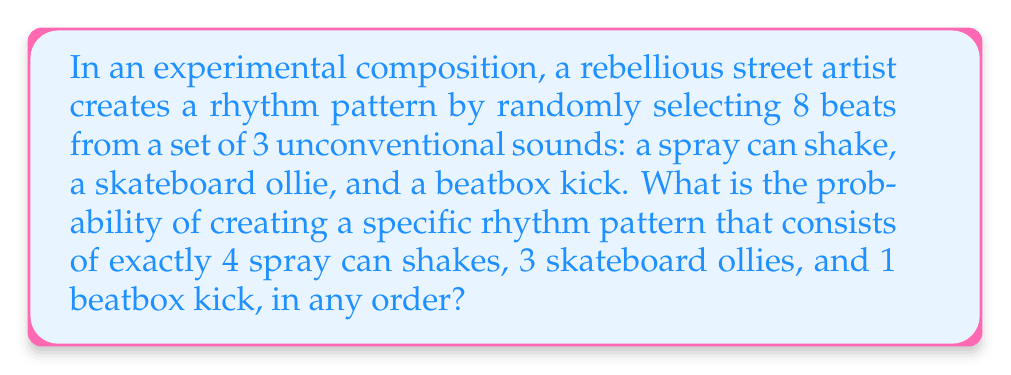Solve this math problem. Let's approach this step-by-step:

1) This is a combination problem where order matters. We can use the multinomial coefficient to solve it.

2) The total number of beats is 8, and we need to distribute them into 3 categories:
   - 4 spray can shakes
   - 3 skateboard ollies
   - 1 beatbox kick

3) The formula for the multinomial coefficient is:

   $$\binom{n}{n_1, n_2, ..., n_k} = \frac{n!}{n_1! \cdot n_2! \cdot ... \cdot n_k!}$$

   Where $n$ is the total number of items, and $n_1, n_2, ..., n_k$ are the number of items in each category.

4) In our case:
   $n = 8$ (total beats)
   $n_1 = 4$ (spray can shakes)
   $n_2 = 3$ (skateboard ollies)
   $n_3 = 1$ (beatbox kick)

5) Plugging these into the formula:

   $$\binom{8}{4, 3, 1} = \frac{8!}{4! \cdot 3! \cdot 1!}$$

6) Calculating this:
   $$\frac{8!}{4! \cdot 3! \cdot 1!} = \frac{40320}{24 \cdot 6 \cdot 1} = 280$$

7) This means there are 280 ways to arrange this specific rhythm pattern.

8) To find the probability, we need to divide this by the total number of possible 8-beat patterns using 3 sounds.

9) The total number of possible patterns is $3^8 = 6561$, as for each of the 8 beats, we have 3 choices.

10) Therefore, the probability is:

    $$\frac{280}{6561} = \frac{40}{937} \approx 0.0427$$
Answer: $\frac{40}{937}$ 